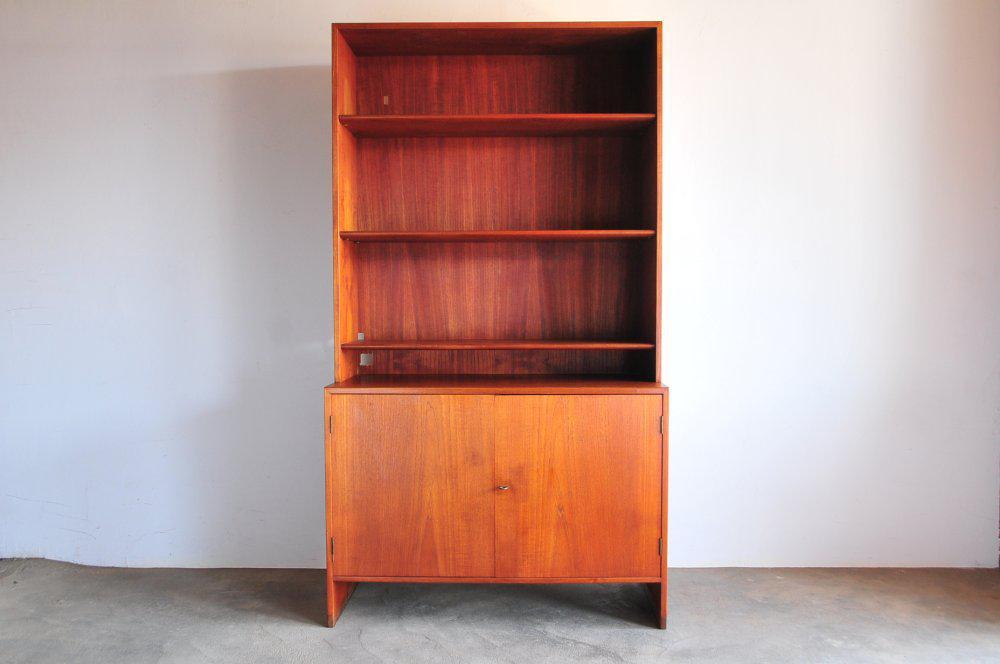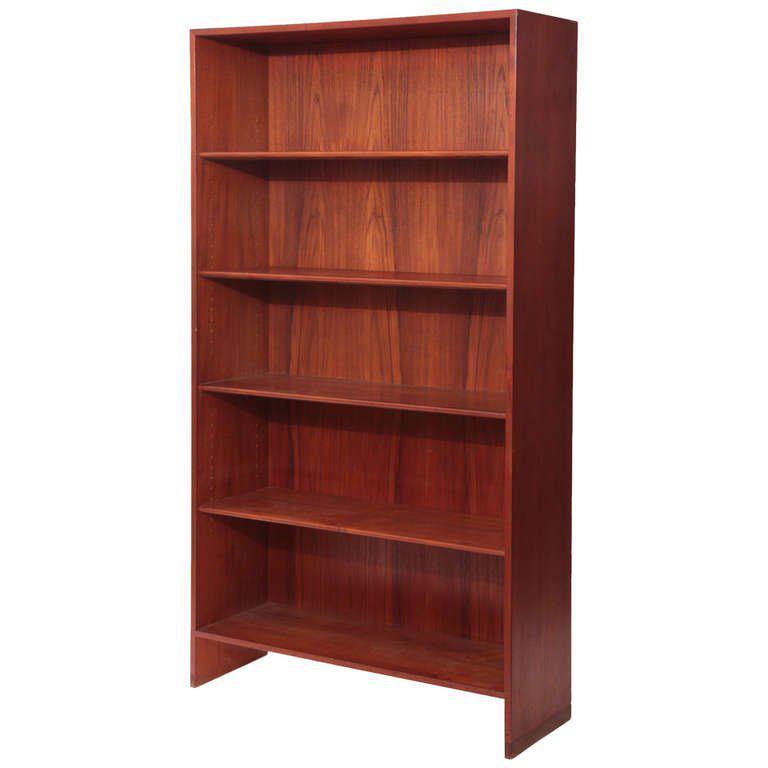The first image is the image on the left, the second image is the image on the right. For the images shown, is this caption "One piece of furniture has exactly five shelves." true? Answer yes or no. Yes. The first image is the image on the left, the second image is the image on the right. Given the left and right images, does the statement "One image contains a tall, brown bookshelf; and the other contains a bookshelf with cupboards at the bottom." hold true? Answer yes or no. Yes. 